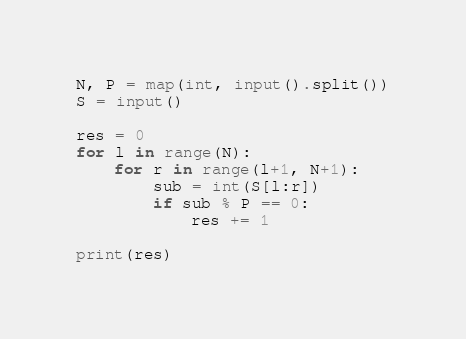<code> <loc_0><loc_0><loc_500><loc_500><_Python_>N, P = map(int, input().split())
S = input()

res = 0
for l in range(N):
    for r in range(l+1, N+1):
        sub = int(S[l:r])
        if sub % P == 0:
            res += 1

print(res)</code> 